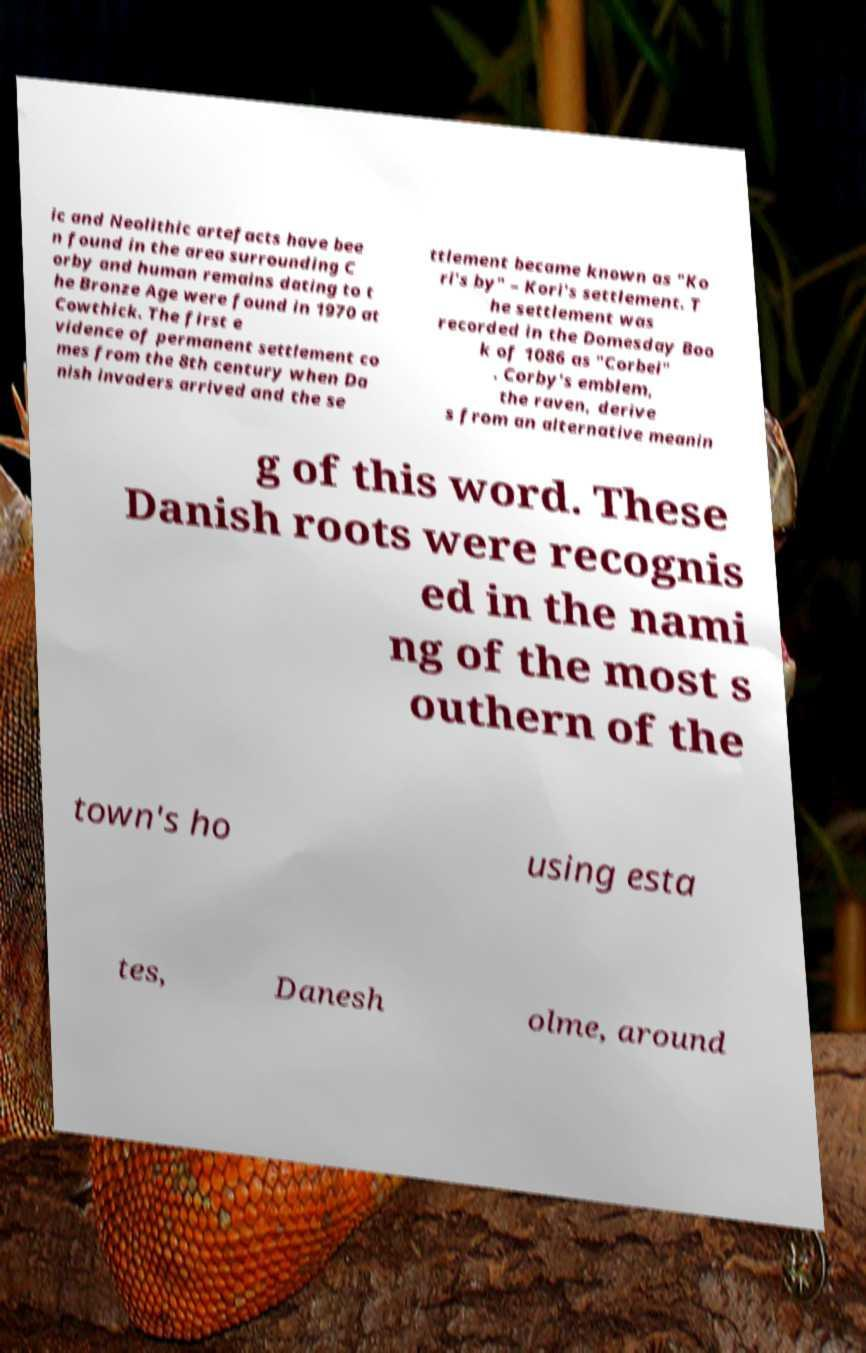Please read and relay the text visible in this image. What does it say? ic and Neolithic artefacts have bee n found in the area surrounding C orby and human remains dating to t he Bronze Age were found in 1970 at Cowthick. The first e vidence of permanent settlement co mes from the 8th century when Da nish invaders arrived and the se ttlement became known as "Ko ri's by" – Kori's settlement. T he settlement was recorded in the Domesday Boo k of 1086 as "Corbei" . Corby's emblem, the raven, derive s from an alternative meanin g of this word. These Danish roots were recognis ed in the nami ng of the most s outhern of the town's ho using esta tes, Danesh olme, around 